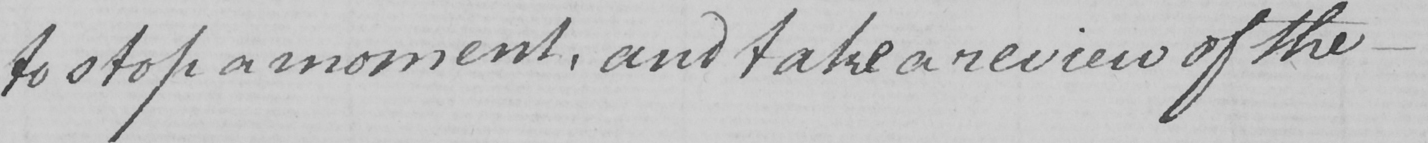Can you read and transcribe this handwriting? to stop a moment , and take a review of the  _ 